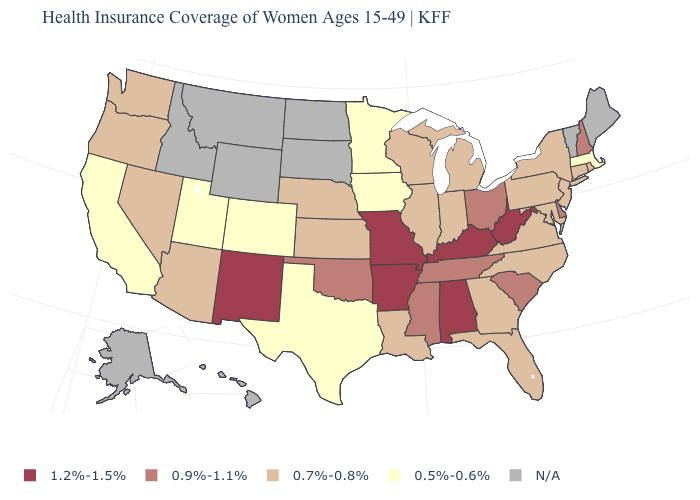What is the lowest value in the MidWest?
Give a very brief answer. 0.5%-0.6%. What is the value of Louisiana?
Answer briefly. 0.7%-0.8%. What is the value of Delaware?
Write a very short answer. 0.9%-1.1%. What is the lowest value in the USA?
Write a very short answer. 0.5%-0.6%. What is the highest value in states that border Oklahoma?
Short answer required. 1.2%-1.5%. What is the lowest value in the West?
Concise answer only. 0.5%-0.6%. Name the states that have a value in the range 0.5%-0.6%?
Write a very short answer. California, Colorado, Iowa, Massachusetts, Minnesota, Texas, Utah. What is the value of New York?
Write a very short answer. 0.7%-0.8%. How many symbols are there in the legend?
Quick response, please. 5. Among the states that border Idaho , does Utah have the lowest value?
Give a very brief answer. Yes. Name the states that have a value in the range 0.9%-1.1%?
Answer briefly. Delaware, Mississippi, New Hampshire, Ohio, Oklahoma, South Carolina, Tennessee. Name the states that have a value in the range N/A?
Concise answer only. Alaska, Hawaii, Idaho, Maine, Montana, North Dakota, South Dakota, Vermont, Wyoming. What is the lowest value in states that border Georgia?
Quick response, please. 0.7%-0.8%. What is the lowest value in the MidWest?
Give a very brief answer. 0.5%-0.6%. Which states have the lowest value in the USA?
Short answer required. California, Colorado, Iowa, Massachusetts, Minnesota, Texas, Utah. 